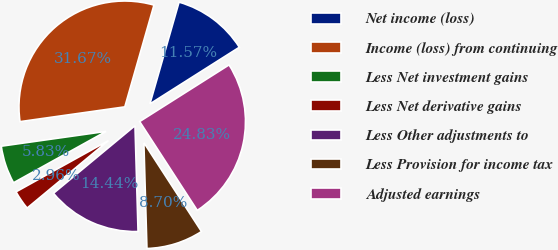Convert chart to OTSL. <chart><loc_0><loc_0><loc_500><loc_500><pie_chart><fcel>Net income (loss)<fcel>Income (loss) from continuing<fcel>Less Net investment gains<fcel>Less Net derivative gains<fcel>Less Other adjustments to<fcel>Less Provision for income tax<fcel>Adjusted earnings<nl><fcel>11.57%<fcel>31.67%<fcel>5.83%<fcel>2.96%<fcel>14.44%<fcel>8.7%<fcel>24.83%<nl></chart> 